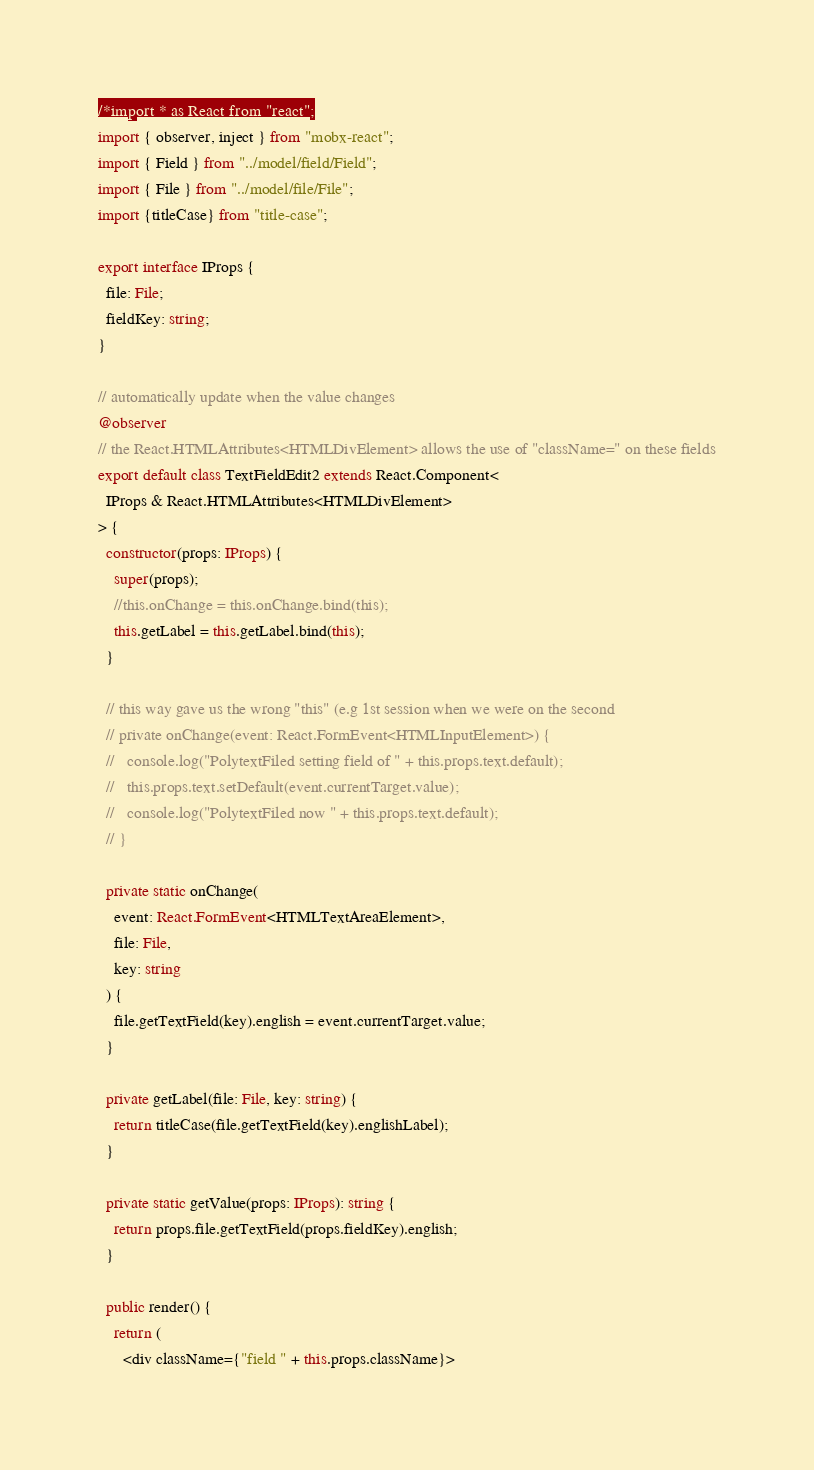Convert code to text. <code><loc_0><loc_0><loc_500><loc_500><_TypeScript_>/*import * as React from "react";
import { observer, inject } from "mobx-react";
import { Field } from "../model/field/Field";
import { File } from "../model/file/File";
import {titleCase} from "title-case";

export interface IProps {
  file: File;
  fieldKey: string;
}

// automatically update when the value changes
@observer
// the React.HTMLAttributes<HTMLDivElement> allows the use of "className=" on these fields
export default class TextFieldEdit2 extends React.Component<
  IProps & React.HTMLAttributes<HTMLDivElement>
> {
  constructor(props: IProps) {
    super(props);
    //this.onChange = this.onChange.bind(this);
    this.getLabel = this.getLabel.bind(this);
  }

  // this way gave us the wrong "this" (e.g 1st session when we were on the second
  // private onChange(event: React.FormEvent<HTMLInputElement>) {
  //   console.log("PolytextFiled setting field of " + this.props.text.default);
  //   this.props.text.setDefault(event.currentTarget.value);
  //   console.log("PolytextFiled now " + this.props.text.default);
  // }

  private static onChange(
    event: React.FormEvent<HTMLTextAreaElement>,
    file: File,
    key: string
  ) {
    file.getTextField(key).english = event.currentTarget.value;
  }

  private getLabel(file: File, key: string) {
    return titleCase(file.getTextField(key).englishLabel);
  }

  private static getValue(props: IProps): string {
    return props.file.getTextField(props.fieldKey).english;
  }

  public render() {
    return (
      <div className={"field " + this.props.className}></code> 